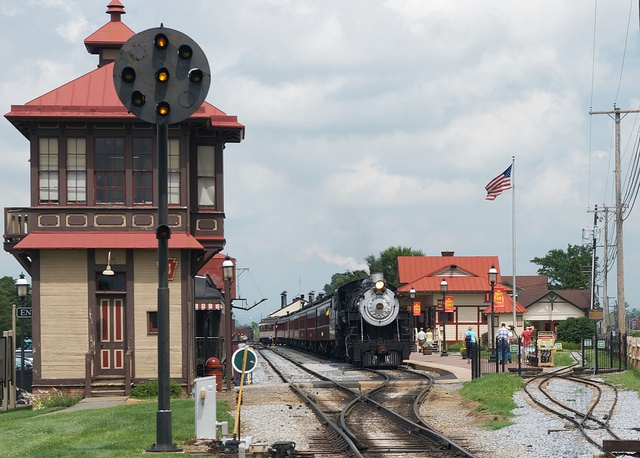Describe the objects in this image and their specific colors. I can see train in lightgray, black, gray, and darkgray tones, traffic light in lightgray, gray, and black tones, people in lightgray, lavender, blue, black, and darkgray tones, people in lightgray, black, lightblue, and gray tones, and people in lightgray, salmon, brown, and maroon tones in this image. 